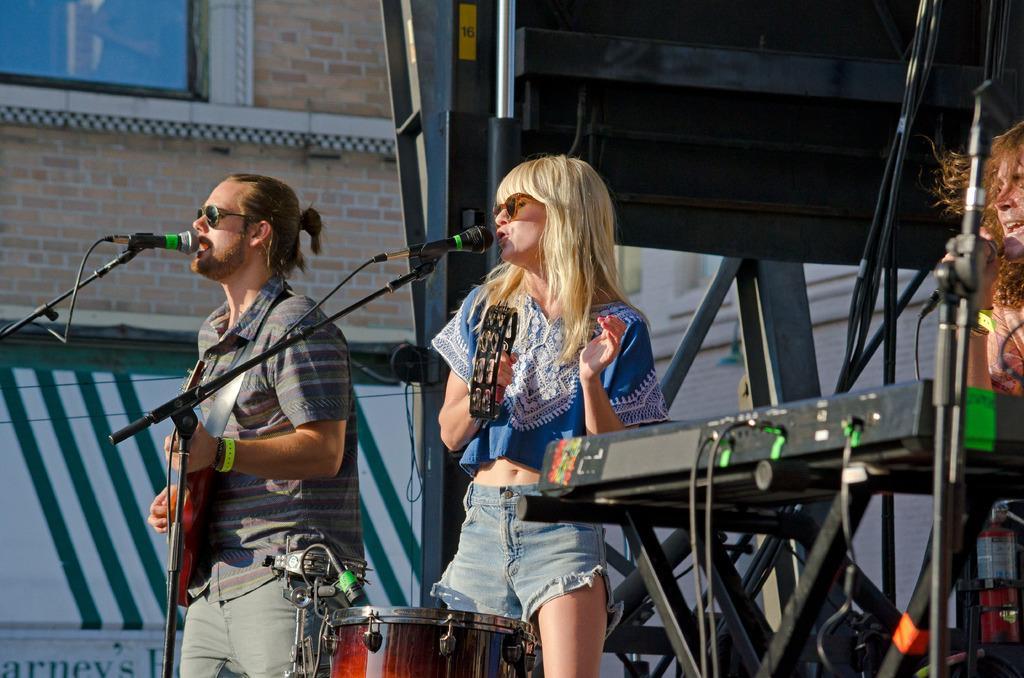Can you describe this image briefly? There are 3 people on the stage performing by playing musical instruments and singing. In the background there is a building,window. 